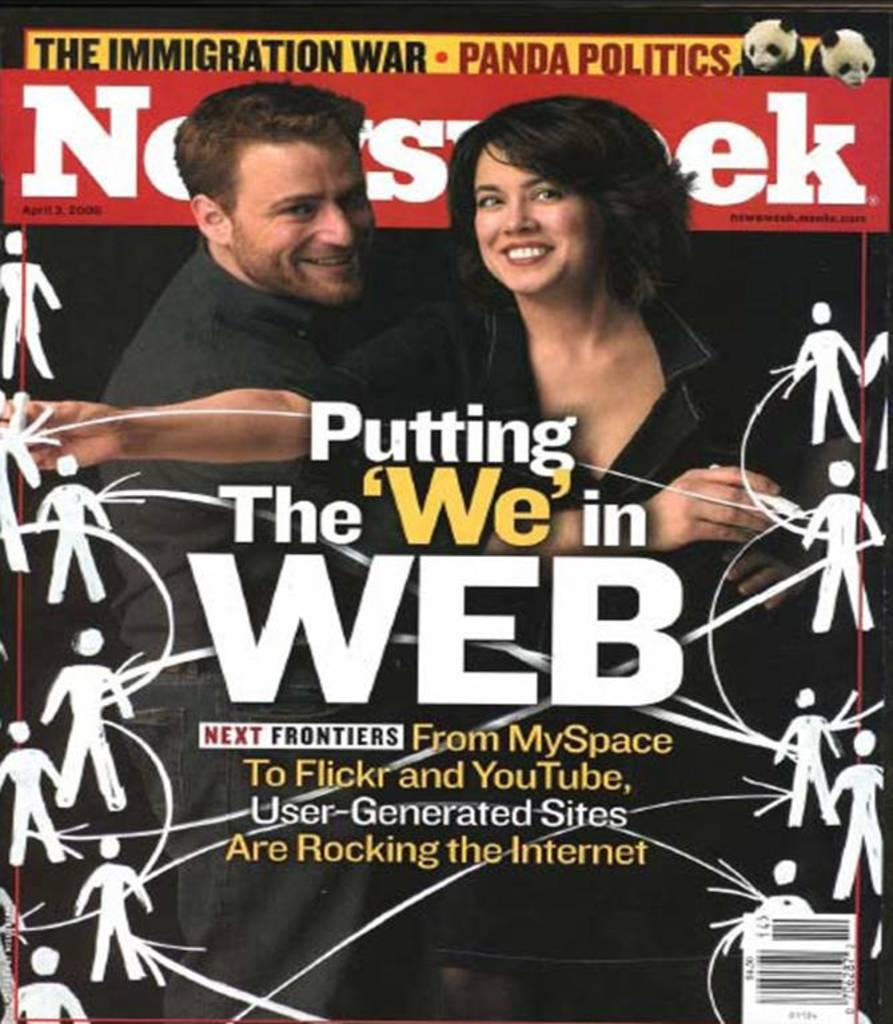<image>
Present a compact description of the photo's key features. a cover of newsweek that says putting "we" in the web. 